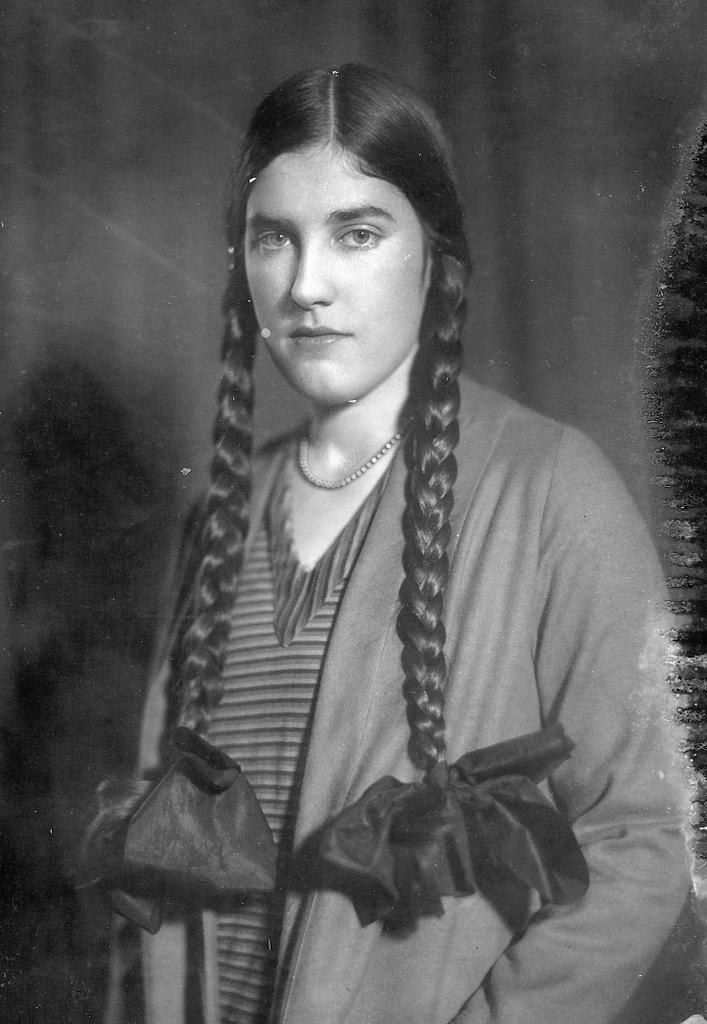Who is the main subject in the image? There is a girl in the image. What is the girl wearing on her upper body? The girl is wearing a coat. What is the girl wearing on her lower body? The girl is wearing a dress. How many horns can be seen on the girl's head in the image? There are no horns visible on the girl's head in the image. 